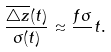<formula> <loc_0><loc_0><loc_500><loc_500>\frac { \overline { \triangle z } ( t ) } { \sigma ( t ) } \approx \frac { f \sigma } { } t .</formula> 